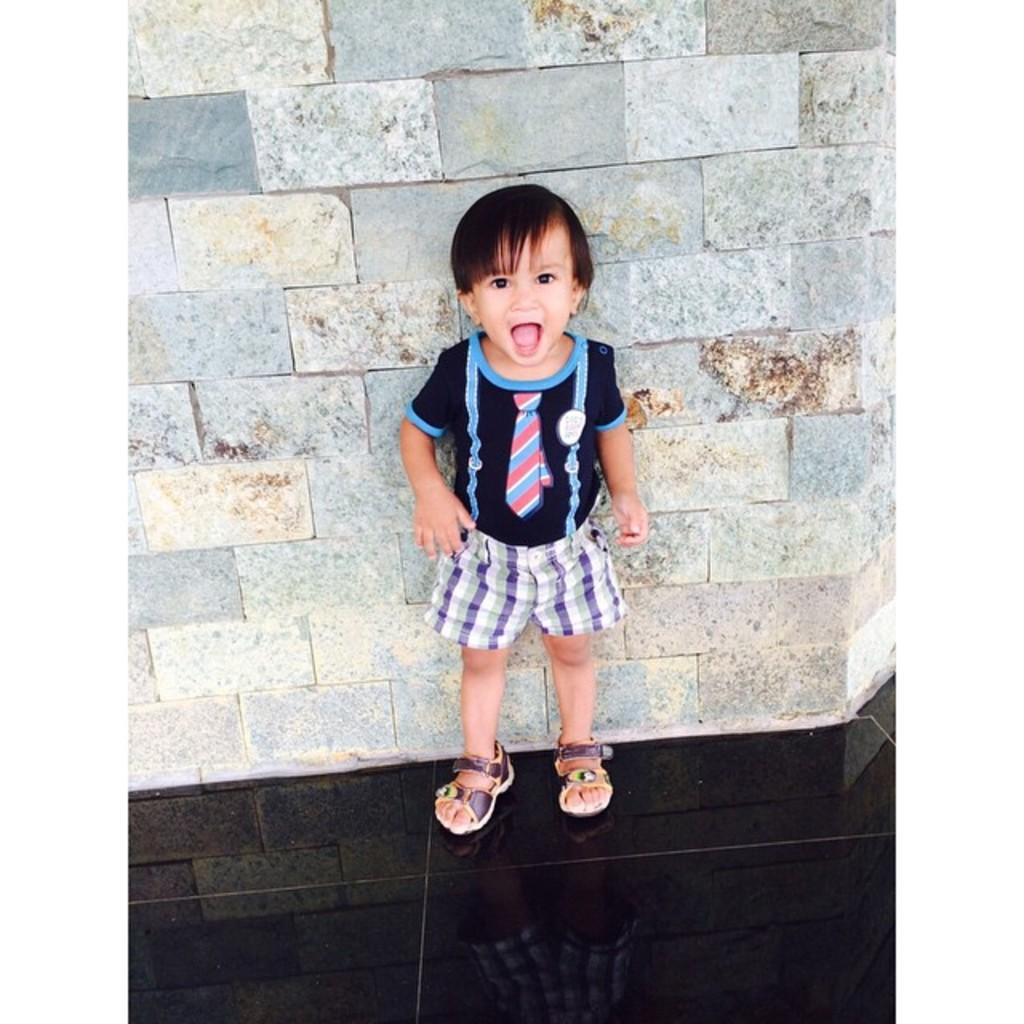What is the main subject of the image? There is a person standing in the image. What is the person wearing? The person is wearing a dress with black, blue, and purple colors. Can you describe the background of the image? The background of the image includes a wall with gray and brown colors. What type of bell can be heard ringing in the image? There is no bell present in the image, and therefore no sound can be heard. Are there any mittens visible on the person's hands in the image? There is no mention of mittens in the provided facts, and no mittens are visible on the person's hands in the image. 